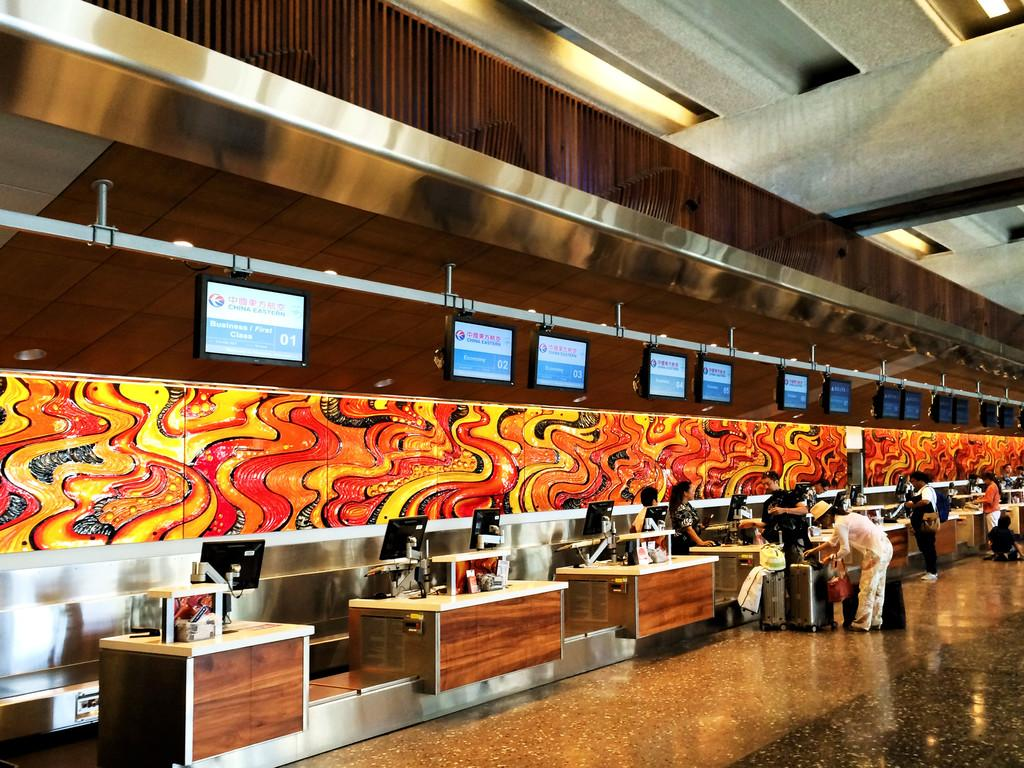What objects are on the table in the image? There are monitors on the table in the image. Who or what can be seen in the image? There are people in the image. What else is visible in the image besides the monitors and people? There is baggage visible in the image. What things do the people in the image hate? There is no information about the people's feelings or preferences in the image, so it cannot be determined what they might hate. Who is the partner of the person in the image? There is no information about a partner or relationship in the image, so it cannot be determined who the partner might be. 